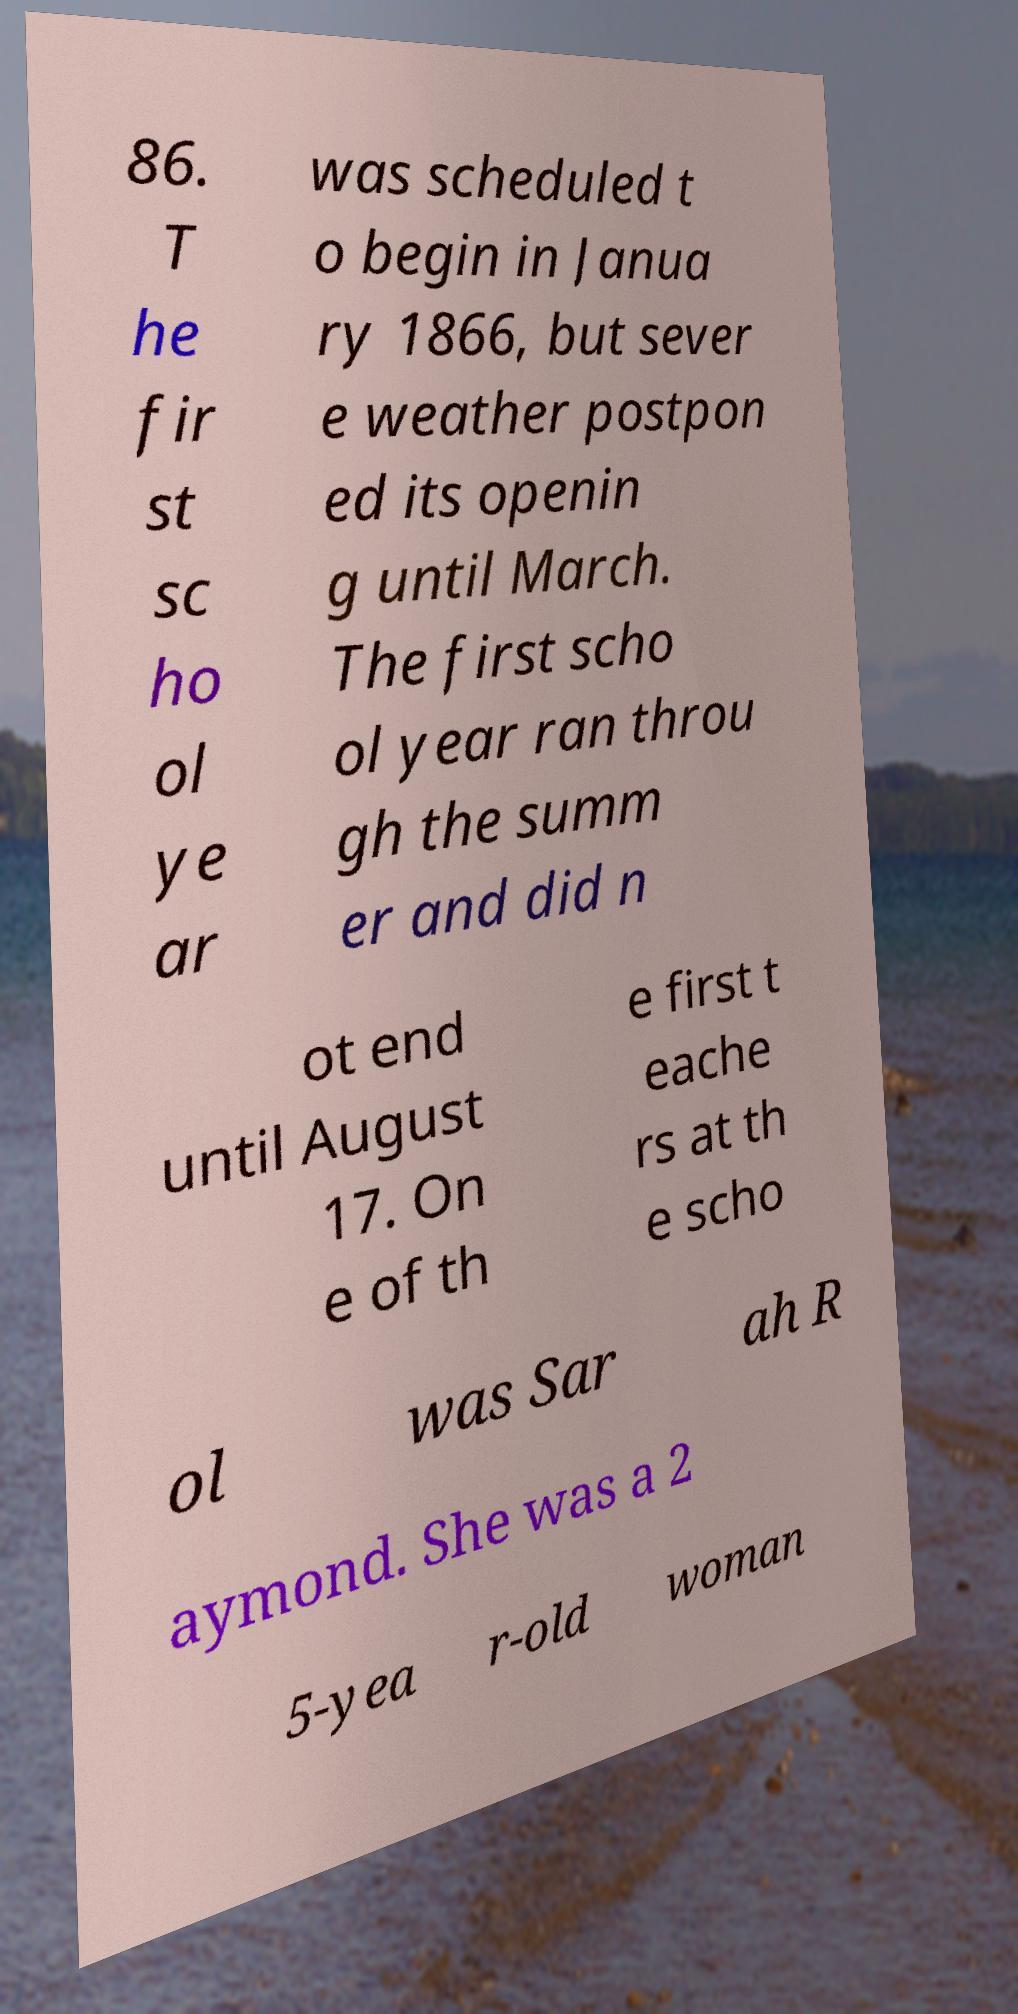What messages or text are displayed in this image? I need them in a readable, typed format. 86. T he fir st sc ho ol ye ar was scheduled t o begin in Janua ry 1866, but sever e weather postpon ed its openin g until March. The first scho ol year ran throu gh the summ er and did n ot end until August 17. On e of th e first t eache rs at th e scho ol was Sar ah R aymond. She was a 2 5-yea r-old woman 